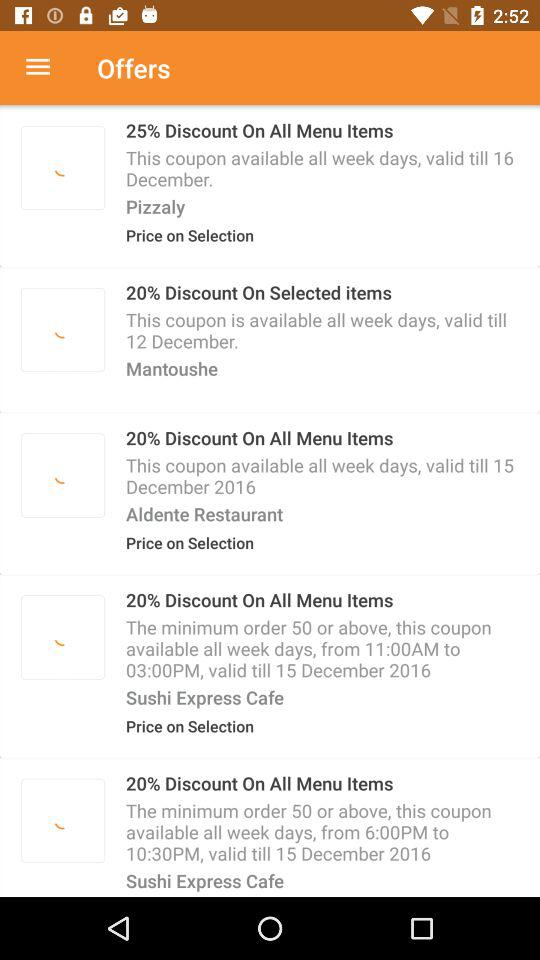How much of a discount is offered at Aldente Restaurant? The offered discount is 20 percent. 